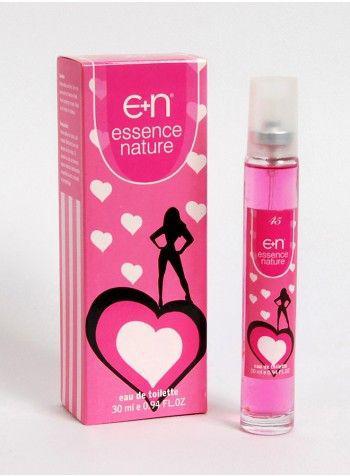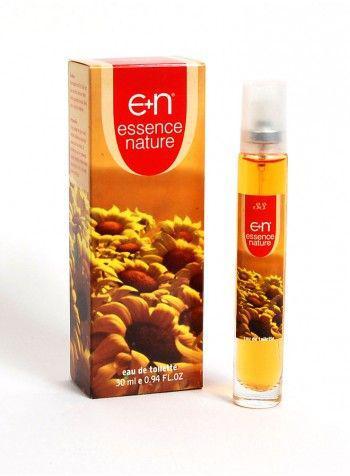The first image is the image on the left, the second image is the image on the right. Analyze the images presented: Is the assertion "Each image shows one upright fragrance bottle to the right of its box, and one of the images features a box with a sports car on its front." valid? Answer yes or no. No. The first image is the image on the left, the second image is the image on the right. Examine the images to the left and right. Is the description "The right image contains a slim container with blue liquid inside it." accurate? Answer yes or no. No. 